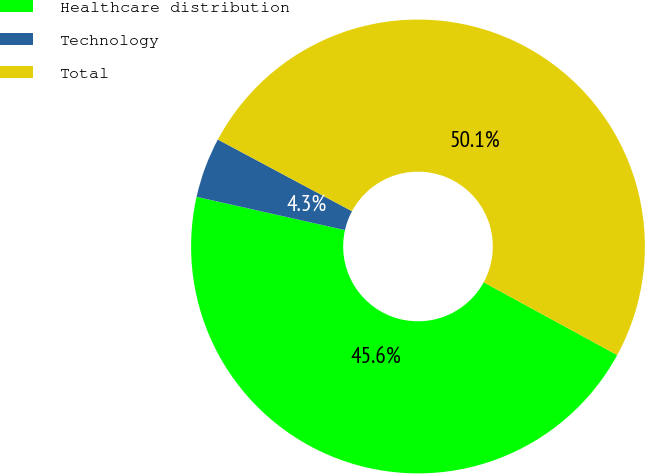Convert chart to OTSL. <chart><loc_0><loc_0><loc_500><loc_500><pie_chart><fcel>Healthcare distribution<fcel>Technology<fcel>Total<nl><fcel>45.57%<fcel>4.3%<fcel>50.13%<nl></chart> 